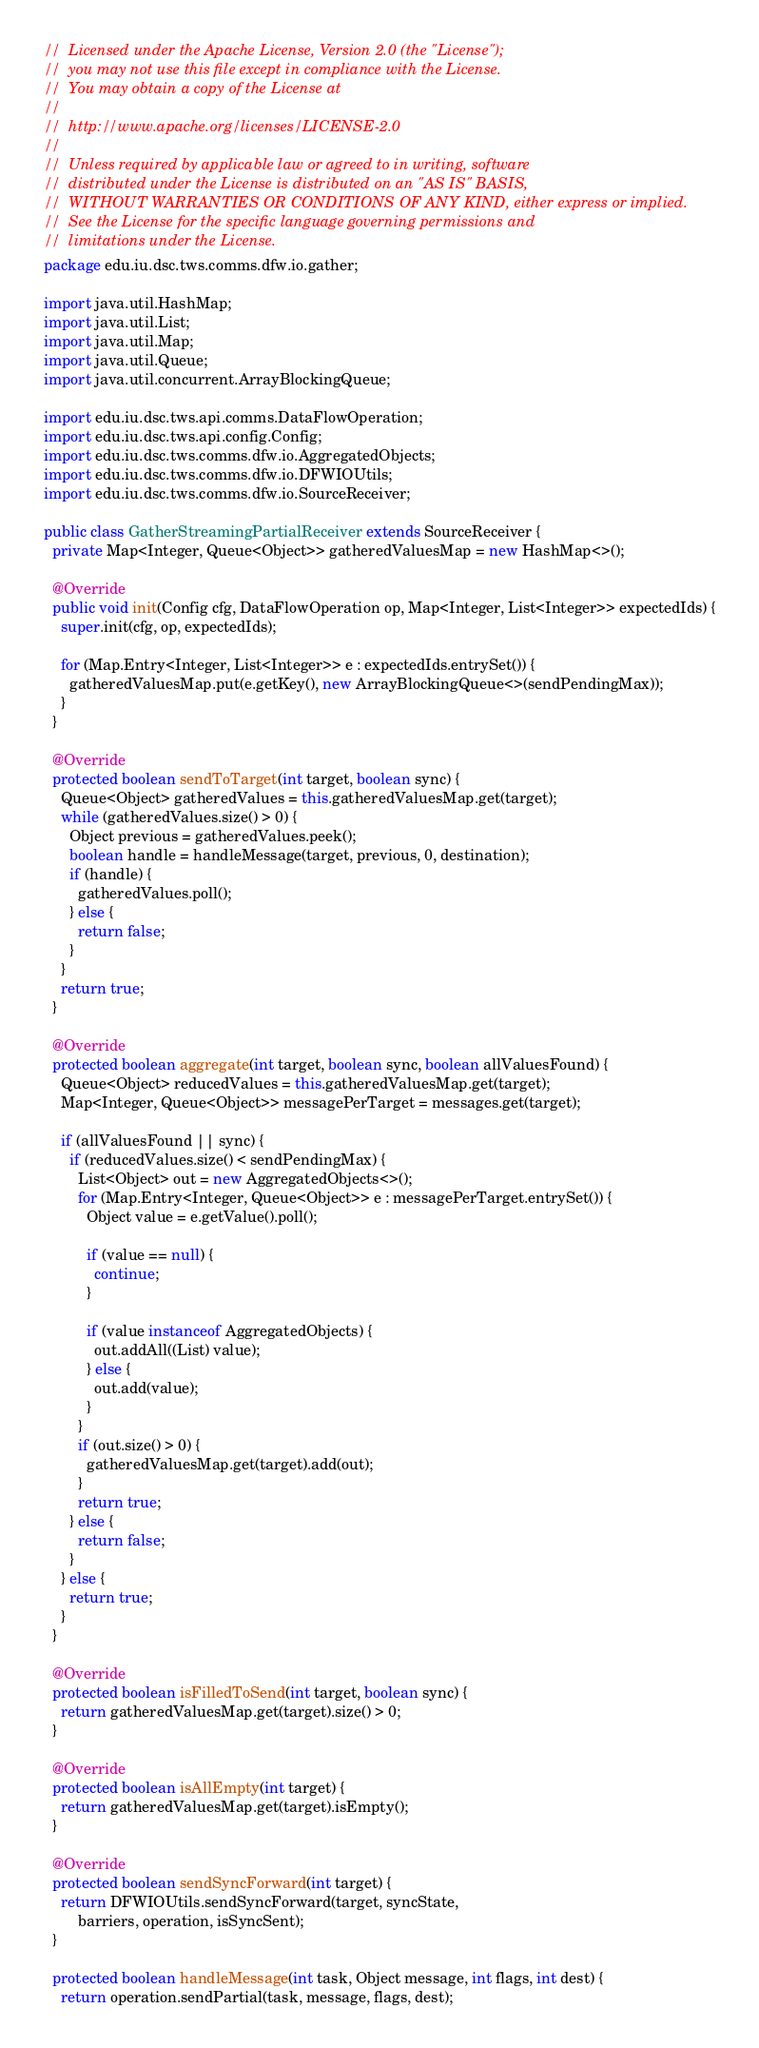Convert code to text. <code><loc_0><loc_0><loc_500><loc_500><_Java_>//  Licensed under the Apache License, Version 2.0 (the "License");
//  you may not use this file except in compliance with the License.
//  You may obtain a copy of the License at
//
//  http://www.apache.org/licenses/LICENSE-2.0
//
//  Unless required by applicable law or agreed to in writing, software
//  distributed under the License is distributed on an "AS IS" BASIS,
//  WITHOUT WARRANTIES OR CONDITIONS OF ANY KIND, either express or implied.
//  See the License for the specific language governing permissions and
//  limitations under the License.
package edu.iu.dsc.tws.comms.dfw.io.gather;

import java.util.HashMap;
import java.util.List;
import java.util.Map;
import java.util.Queue;
import java.util.concurrent.ArrayBlockingQueue;

import edu.iu.dsc.tws.api.comms.DataFlowOperation;
import edu.iu.dsc.tws.api.config.Config;
import edu.iu.dsc.tws.comms.dfw.io.AggregatedObjects;
import edu.iu.dsc.tws.comms.dfw.io.DFWIOUtils;
import edu.iu.dsc.tws.comms.dfw.io.SourceReceiver;

public class GatherStreamingPartialReceiver extends SourceReceiver {
  private Map<Integer, Queue<Object>> gatheredValuesMap = new HashMap<>();

  @Override
  public void init(Config cfg, DataFlowOperation op, Map<Integer, List<Integer>> expectedIds) {
    super.init(cfg, op, expectedIds);

    for (Map.Entry<Integer, List<Integer>> e : expectedIds.entrySet()) {
      gatheredValuesMap.put(e.getKey(), new ArrayBlockingQueue<>(sendPendingMax));
    }
  }

  @Override
  protected boolean sendToTarget(int target, boolean sync) {
    Queue<Object> gatheredValues = this.gatheredValuesMap.get(target);
    while (gatheredValues.size() > 0) {
      Object previous = gatheredValues.peek();
      boolean handle = handleMessage(target, previous, 0, destination);
      if (handle) {
        gatheredValues.poll();
      } else {
        return false;
      }
    }
    return true;
  }

  @Override
  protected boolean aggregate(int target, boolean sync, boolean allValuesFound) {
    Queue<Object> reducedValues = this.gatheredValuesMap.get(target);
    Map<Integer, Queue<Object>> messagePerTarget = messages.get(target);

    if (allValuesFound || sync) {
      if (reducedValues.size() < sendPendingMax) {
        List<Object> out = new AggregatedObjects<>();
        for (Map.Entry<Integer, Queue<Object>> e : messagePerTarget.entrySet()) {
          Object value = e.getValue().poll();

          if (value == null) {
            continue;
          }

          if (value instanceof AggregatedObjects) {
            out.addAll((List) value);
          } else {
            out.add(value);
          }
        }
        if (out.size() > 0) {
          gatheredValuesMap.get(target).add(out);
        }
        return true;
      } else {
        return false;
      }
    } else {
      return true;
    }
  }

  @Override
  protected boolean isFilledToSend(int target, boolean sync) {
    return gatheredValuesMap.get(target).size() > 0;
  }

  @Override
  protected boolean isAllEmpty(int target) {
    return gatheredValuesMap.get(target).isEmpty();
  }

  @Override
  protected boolean sendSyncForward(int target) {
    return DFWIOUtils.sendSyncForward(target, syncState,
        barriers, operation, isSyncSent);
  }

  protected boolean handleMessage(int task, Object message, int flags, int dest) {
    return operation.sendPartial(task, message, flags, dest);</code> 